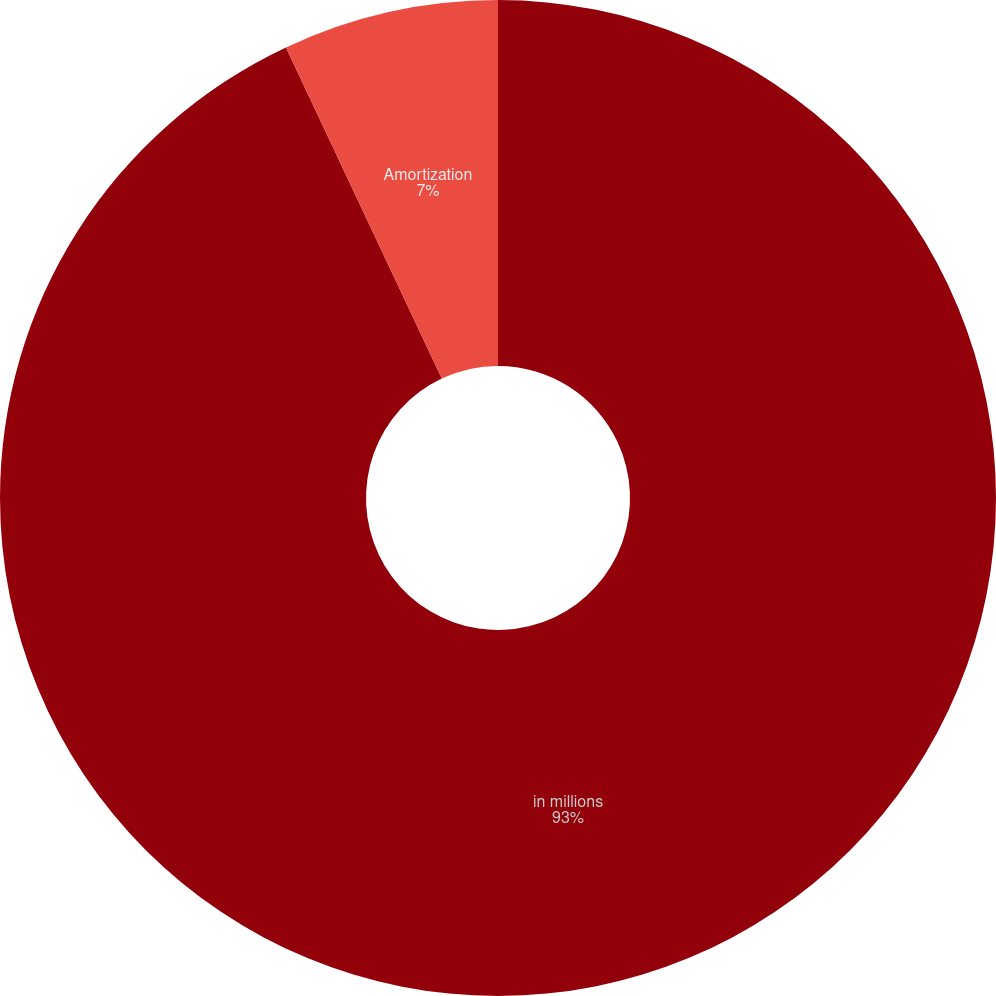<chart> <loc_0><loc_0><loc_500><loc_500><pie_chart><fcel>in millions<fcel>Amortization<nl><fcel>93.0%<fcel>7.0%<nl></chart> 